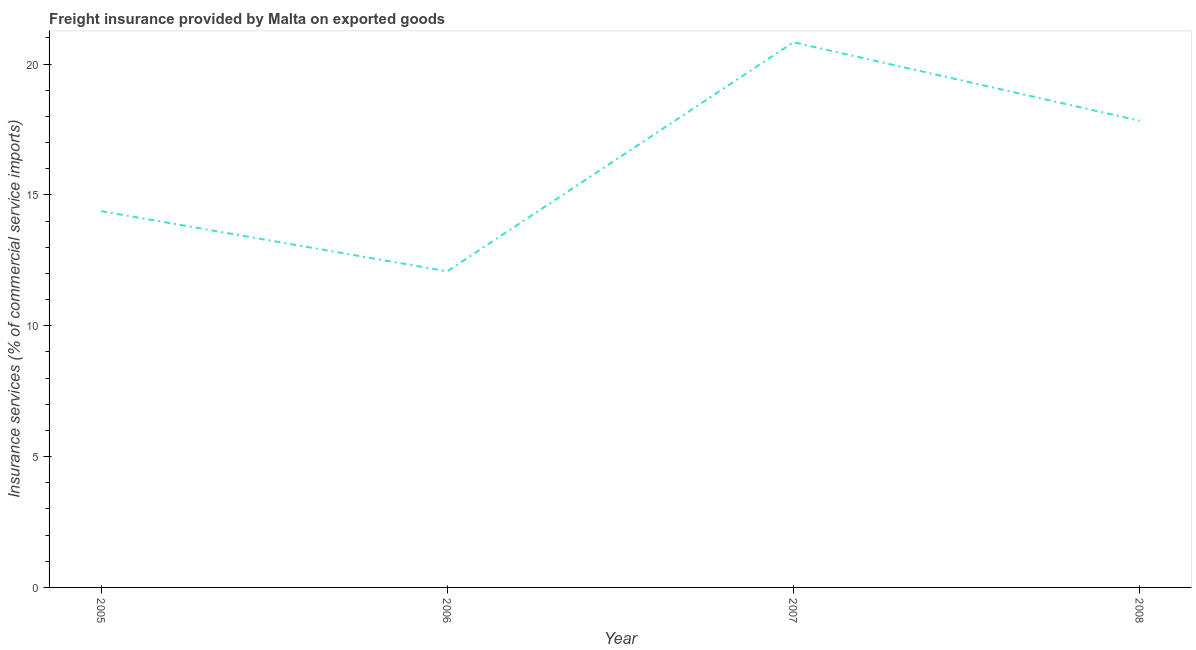What is the freight insurance in 2007?
Your answer should be compact. 20.83. Across all years, what is the maximum freight insurance?
Your answer should be very brief. 20.83. Across all years, what is the minimum freight insurance?
Offer a terse response. 12.08. In which year was the freight insurance maximum?
Your response must be concise. 2007. What is the sum of the freight insurance?
Offer a terse response. 65.12. What is the difference between the freight insurance in 2005 and 2006?
Your answer should be compact. 2.3. What is the average freight insurance per year?
Your answer should be very brief. 16.28. What is the median freight insurance?
Ensure brevity in your answer.  16.11. What is the ratio of the freight insurance in 2005 to that in 2006?
Give a very brief answer. 1.19. Is the freight insurance in 2006 less than that in 2007?
Provide a short and direct response. Yes. What is the difference between the highest and the second highest freight insurance?
Provide a succinct answer. 3. What is the difference between the highest and the lowest freight insurance?
Offer a terse response. 8.75. In how many years, is the freight insurance greater than the average freight insurance taken over all years?
Your answer should be compact. 2. Does the freight insurance monotonically increase over the years?
Ensure brevity in your answer.  No. What is the difference between two consecutive major ticks on the Y-axis?
Offer a terse response. 5. Does the graph contain any zero values?
Your response must be concise. No. What is the title of the graph?
Give a very brief answer. Freight insurance provided by Malta on exported goods . What is the label or title of the Y-axis?
Your answer should be very brief. Insurance services (% of commercial service imports). What is the Insurance services (% of commercial service imports) of 2005?
Your response must be concise. 14.38. What is the Insurance services (% of commercial service imports) in 2006?
Your answer should be very brief. 12.08. What is the Insurance services (% of commercial service imports) of 2007?
Your response must be concise. 20.83. What is the Insurance services (% of commercial service imports) in 2008?
Keep it short and to the point. 17.83. What is the difference between the Insurance services (% of commercial service imports) in 2005 and 2006?
Provide a short and direct response. 2.3. What is the difference between the Insurance services (% of commercial service imports) in 2005 and 2007?
Give a very brief answer. -6.45. What is the difference between the Insurance services (% of commercial service imports) in 2005 and 2008?
Give a very brief answer. -3.45. What is the difference between the Insurance services (% of commercial service imports) in 2006 and 2007?
Ensure brevity in your answer.  -8.75. What is the difference between the Insurance services (% of commercial service imports) in 2006 and 2008?
Your response must be concise. -5.75. What is the difference between the Insurance services (% of commercial service imports) in 2007 and 2008?
Provide a succinct answer. 3. What is the ratio of the Insurance services (% of commercial service imports) in 2005 to that in 2006?
Ensure brevity in your answer.  1.19. What is the ratio of the Insurance services (% of commercial service imports) in 2005 to that in 2007?
Give a very brief answer. 0.69. What is the ratio of the Insurance services (% of commercial service imports) in 2005 to that in 2008?
Provide a short and direct response. 0.81. What is the ratio of the Insurance services (% of commercial service imports) in 2006 to that in 2007?
Provide a succinct answer. 0.58. What is the ratio of the Insurance services (% of commercial service imports) in 2006 to that in 2008?
Your answer should be very brief. 0.68. What is the ratio of the Insurance services (% of commercial service imports) in 2007 to that in 2008?
Give a very brief answer. 1.17. 